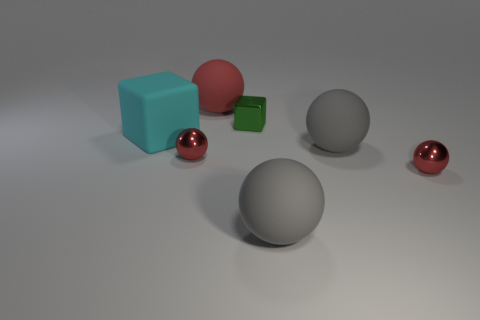Can you tell the approximate scale or sizes of the objects in relation to each other? While no absolute scale is given, we can infer relative sizes. The cyan cube is the largest object, followed by the grey sphere. The red polished sphere seems slightly smaller than the grey one. The small red matte sphere and the green cube are the smallest objects, with the green cube being slightly larger than its red spherical counterpart. 